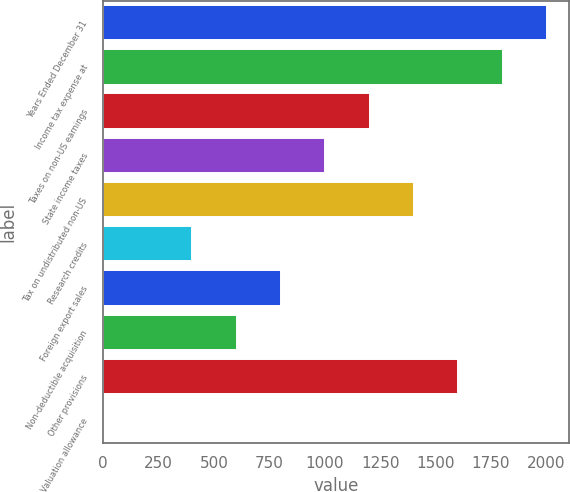Convert chart to OTSL. <chart><loc_0><loc_0><loc_500><loc_500><bar_chart><fcel>Years Ended December 31<fcel>Income tax expense at<fcel>Taxes on non-US earnings<fcel>State income taxes<fcel>Tax on undistributed non-US<fcel>Research credits<fcel>Foreign export sales<fcel>Non-deductible acquisition<fcel>Other provisions<fcel>Valuation allowance<nl><fcel>2003<fcel>1802.9<fcel>1202.6<fcel>1002.5<fcel>1402.7<fcel>402.2<fcel>802.4<fcel>602.3<fcel>1602.8<fcel>2<nl></chart> 